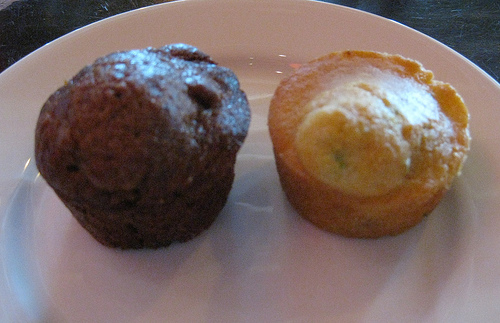<image>
Is the food on the table? Yes. Looking at the image, I can see the food is positioned on top of the table, with the table providing support. Is there a plate in front of the food? No. The plate is not in front of the food. The spatial positioning shows a different relationship between these objects. 